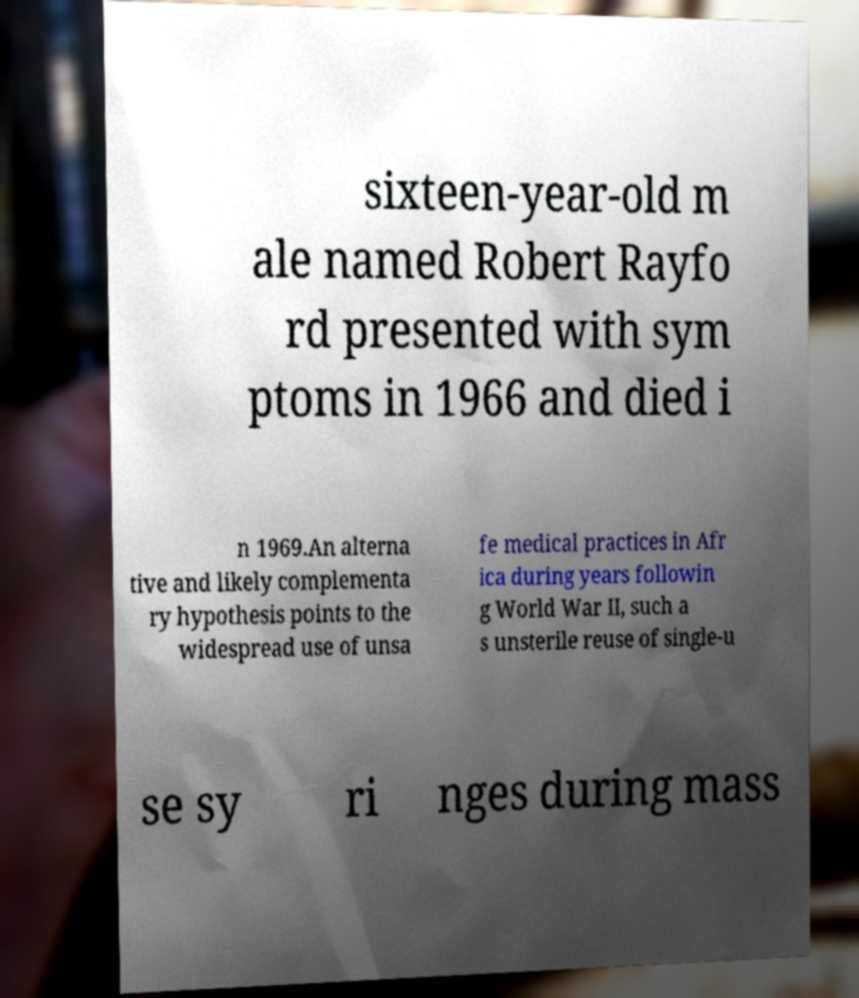Could you extract and type out the text from this image? sixteen-year-old m ale named Robert Rayfo rd presented with sym ptoms in 1966 and died i n 1969.An alterna tive and likely complementa ry hypothesis points to the widespread use of unsa fe medical practices in Afr ica during years followin g World War II, such a s unsterile reuse of single-u se sy ri nges during mass 